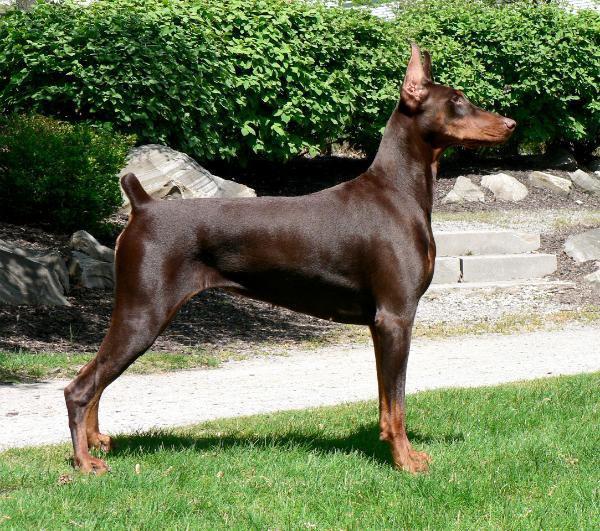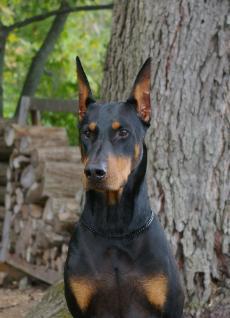The first image is the image on the left, the second image is the image on the right. Evaluate the accuracy of this statement regarding the images: "The left and right image contains the same number of dogs with one facing forward and the other facing sideways.". Is it true? Answer yes or no. Yes. The first image is the image on the left, the second image is the image on the right. For the images shown, is this caption "Two dogs are standing." true? Answer yes or no. No. 